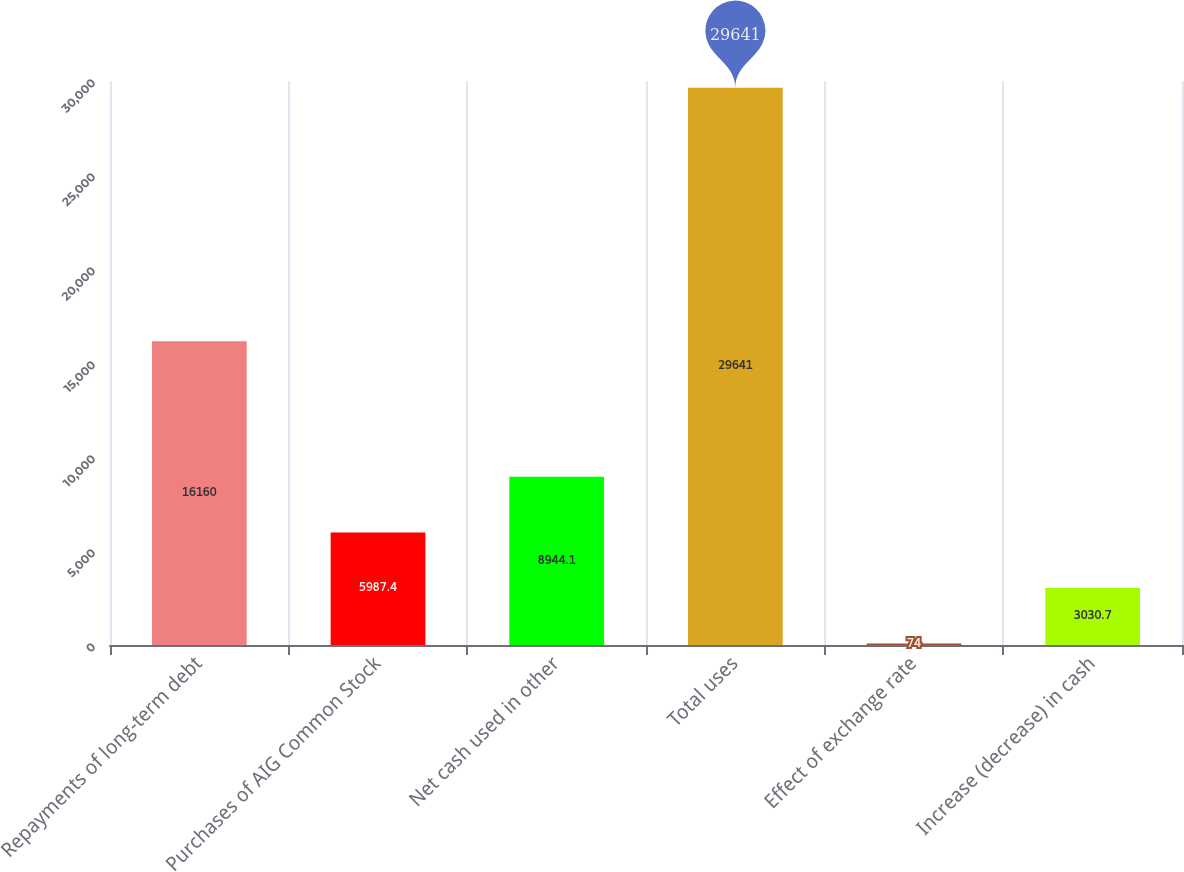Convert chart to OTSL. <chart><loc_0><loc_0><loc_500><loc_500><bar_chart><fcel>Repayments of long-term debt<fcel>Purchases of AIG Common Stock<fcel>Net cash used in other<fcel>Total uses<fcel>Effect of exchange rate<fcel>Increase (decrease) in cash<nl><fcel>16160<fcel>5987.4<fcel>8944.1<fcel>29641<fcel>74<fcel>3030.7<nl></chart> 